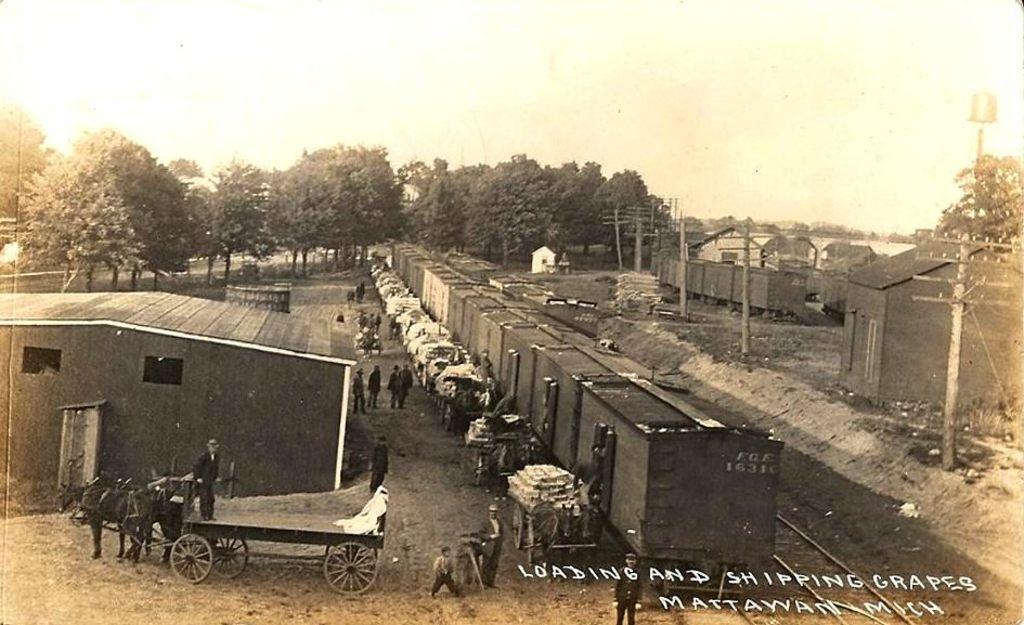Could you give a brief overview of what you see in this image? In this image there is the sky towards the top of the image, there are trees, there are houses, there are poles, there is a horse tonga, there are group of persons standing, there is a train, there is a railway track towards the bottom of the image, there is text towards the bottom of the image. 